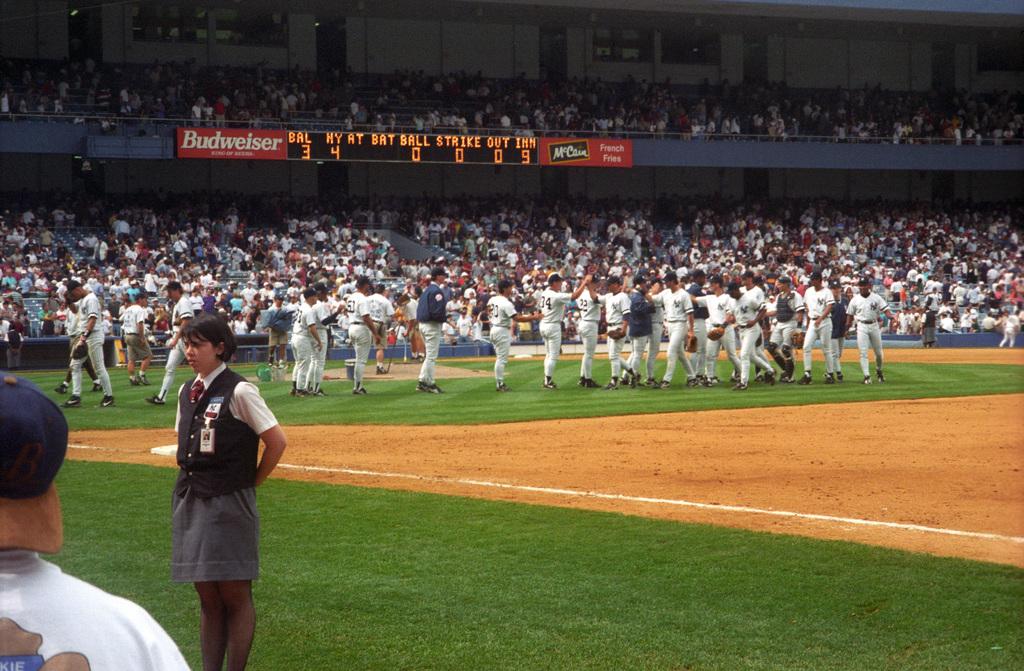What was the final score of the game?
Your answer should be very brief. 3-4. What does the red banner say?
Keep it short and to the point. Budweiser. 